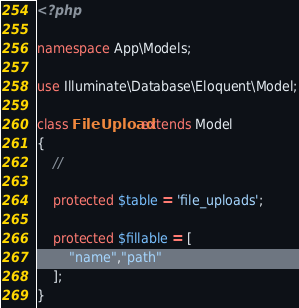<code> <loc_0><loc_0><loc_500><loc_500><_PHP_><?php

namespace App\Models;

use Illuminate\Database\Eloquent\Model;

class FileUpload extends Model
{
    //

    protected $table = 'file_uploads';

    protected $fillable = [
        "name","path"
    ];
}
</code> 